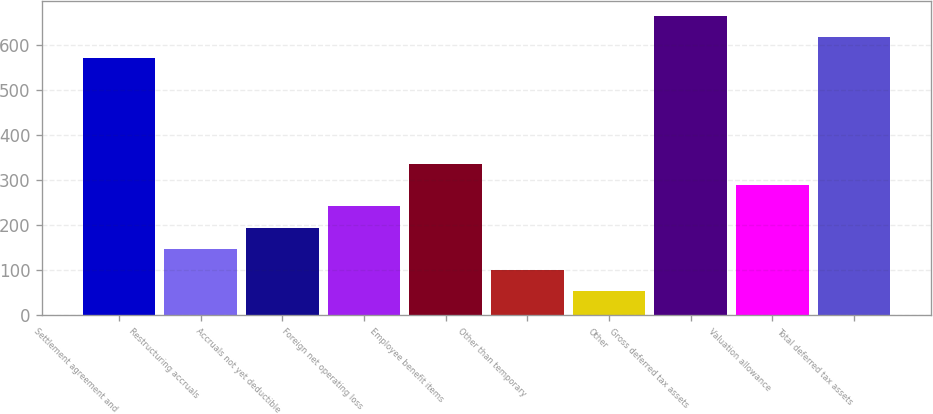Convert chart. <chart><loc_0><loc_0><loc_500><loc_500><bar_chart><fcel>Settlement agreement and<fcel>Restructuring accruals<fcel>Accruals not yet deductible<fcel>Foreign net operating loss<fcel>Employee benefit items<fcel>Other than temporary<fcel>Other<fcel>Gross deferred tax assets<fcel>Valuation allowance<fcel>Total deferred tax assets<nl><fcel>570.34<fcel>147.16<fcel>194.18<fcel>241.2<fcel>335.24<fcel>100.14<fcel>53.12<fcel>664.38<fcel>288.22<fcel>617.36<nl></chart> 